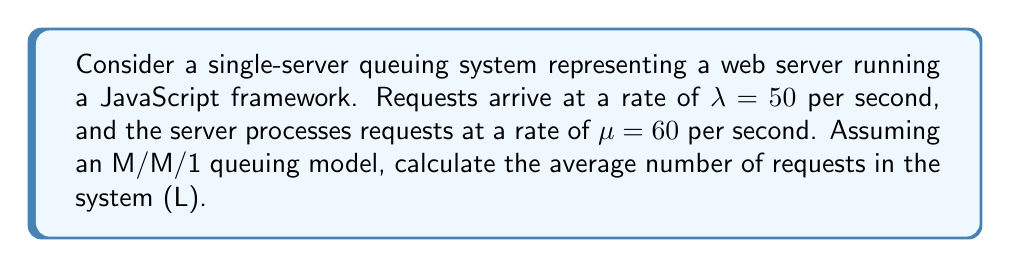Give your solution to this math problem. To solve this problem, we'll use the M/M/1 queuing model, which is appropriate for modeling a single-server system with Poisson arrival and exponential service times. As a frontend developer, you can think of this as modeling how a JavaScript framework handles incoming requests.

Step 1: Calculate the utilization factor $\rho$
The utilization factor is the ratio of arrival rate to service rate:
$$\rho = \frac{\lambda}{\mu} = \frac{50}{60} = \frac{5}{6} \approx 0.833$$

Step 2: Use the formula for average number of requests in the system (L)
For an M/M/1 queue, the average number of requests in the system is given by:
$$L = \frac{\rho}{1 - \rho}$$

Step 3: Substitute the calculated $\rho$ value
$$L = \frac{\frac{5}{6}}{1 - \frac{5}{6}} = \frac{\frac{5}{6}}{\frac{1}{6}} = 5$$

Therefore, the average number of requests in the system is 5.

This result indicates that, on average, there are 5 requests in the system at any given time, including the one being processed and those waiting in the queue. This metric can help you understand how well your JavaScript framework is handling the incoming load and whether you might need to optimize its performance or consider scaling your server resources.
Answer: $L = 5$ requests 